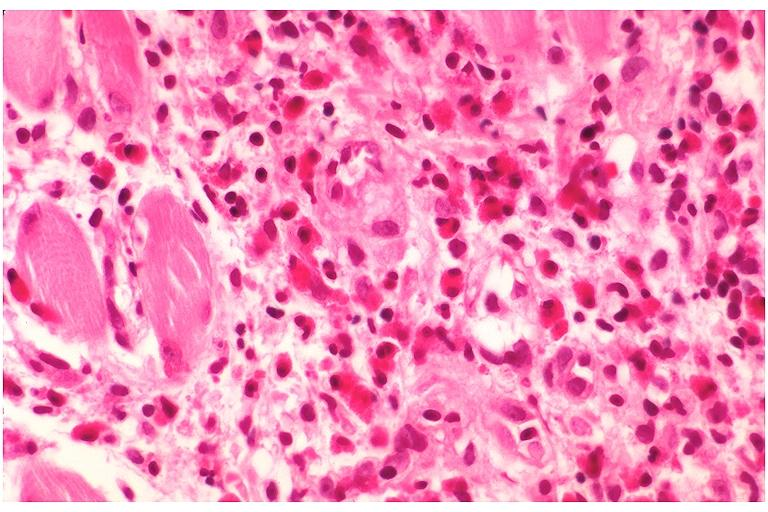s oral present?
Answer the question using a single word or phrase. Yes 